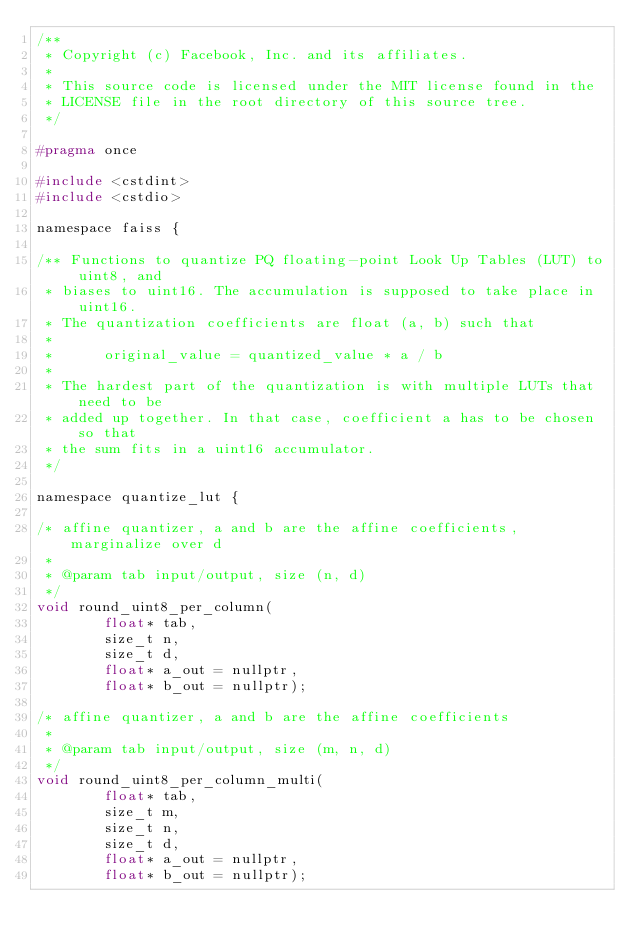Convert code to text. <code><loc_0><loc_0><loc_500><loc_500><_C_>/**
 * Copyright (c) Facebook, Inc. and its affiliates.
 *
 * This source code is licensed under the MIT license found in the
 * LICENSE file in the root directory of this source tree.
 */

#pragma once

#include <cstdint>
#include <cstdio>

namespace faiss {

/** Functions to quantize PQ floating-point Look Up Tables (LUT) to uint8, and
 * biases to uint16. The accumulation is supposed to take place in uint16.
 * The quantization coefficients are float (a, b) such that
 *
 *      original_value = quantized_value * a / b
 *
 * The hardest part of the quantization is with multiple LUTs that need to be
 * added up together. In that case, coefficient a has to be chosen so that
 * the sum fits in a uint16 accumulator.
 */

namespace quantize_lut {

/* affine quantizer, a and b are the affine coefficients, marginalize over d
 *
 * @param tab input/output, size (n, d)
 */
void round_uint8_per_column(
        float* tab,
        size_t n,
        size_t d,
        float* a_out = nullptr,
        float* b_out = nullptr);

/* affine quantizer, a and b are the affine coefficients
 *
 * @param tab input/output, size (m, n, d)
 */
void round_uint8_per_column_multi(
        float* tab,
        size_t m,
        size_t n,
        size_t d,
        float* a_out = nullptr,
        float* b_out = nullptr);
</code> 